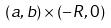Convert formula to latex. <formula><loc_0><loc_0><loc_500><loc_500>( a , b ) \times ( - R , 0 )</formula> 